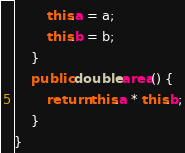Convert code to text. <code><loc_0><loc_0><loc_500><loc_500><_Java_>        this.a = a;
        this.b = b;
    }
    public double area() {
        return this.a * this.b;
    }
}
</code> 